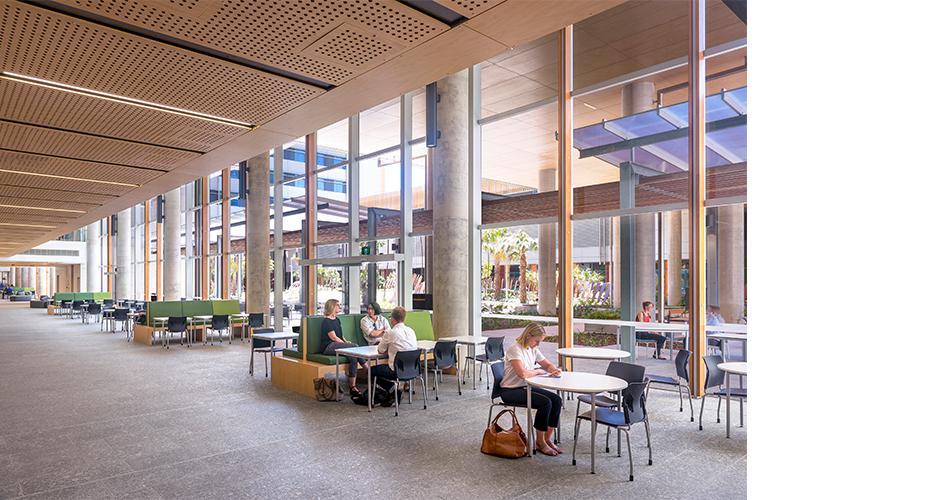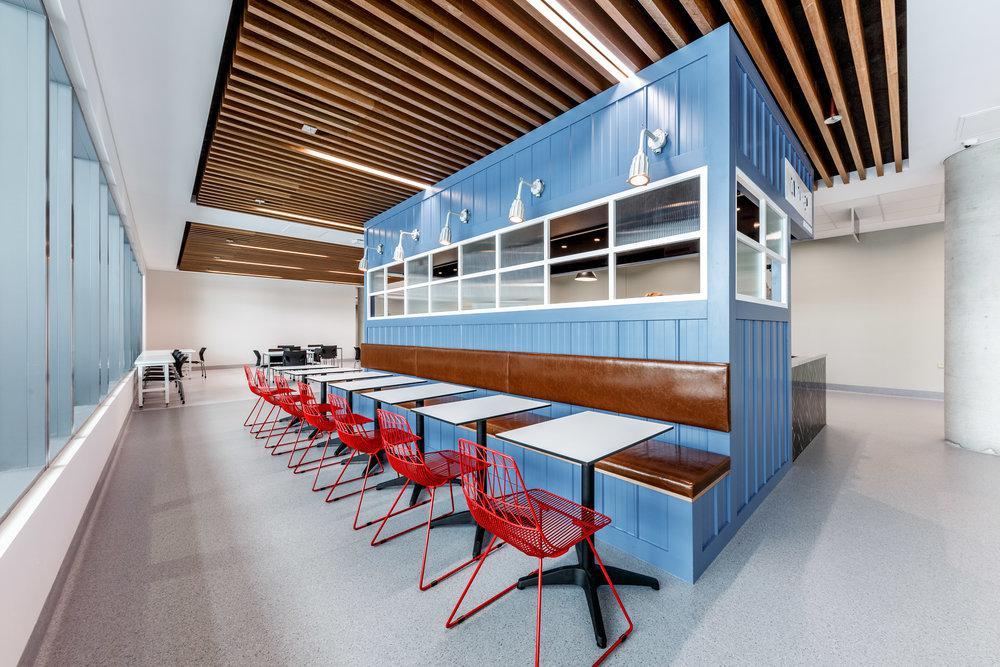The first image is the image on the left, the second image is the image on the right. Analyze the images presented: Is the assertion "In at least one image, there is a total of two people." valid? Answer yes or no. No. 